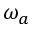Convert formula to latex. <formula><loc_0><loc_0><loc_500><loc_500>\omega _ { a }</formula> 